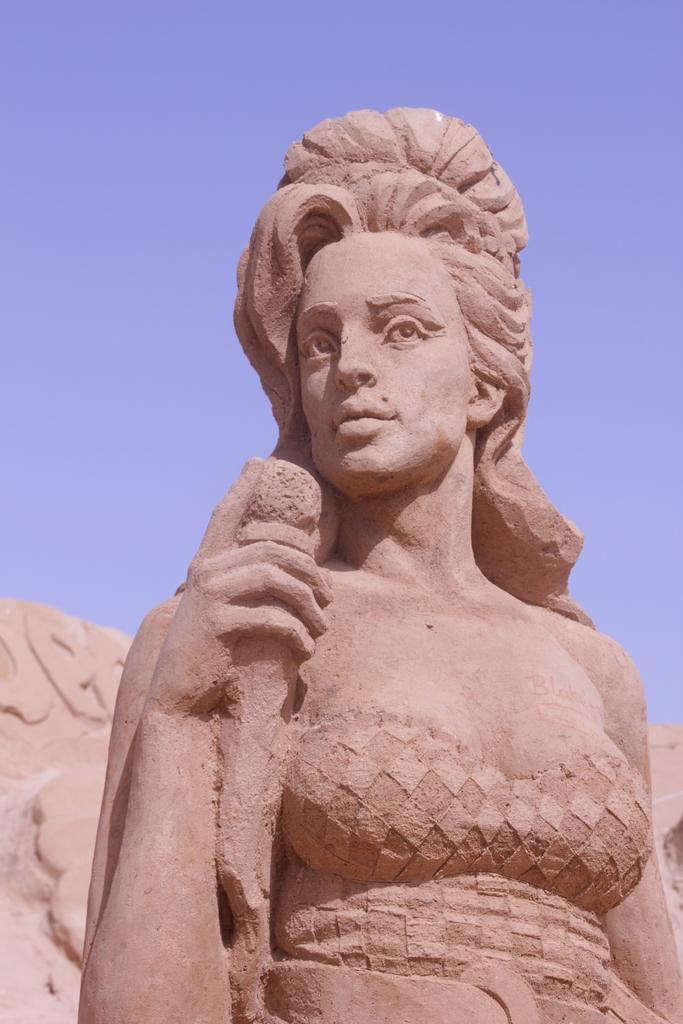What is the main subject of the image? There is a sculpture in the center of the image. What type of locket is hanging from the sculpture in the image? There is no locket present in the image; the main subject is a sculpture. 